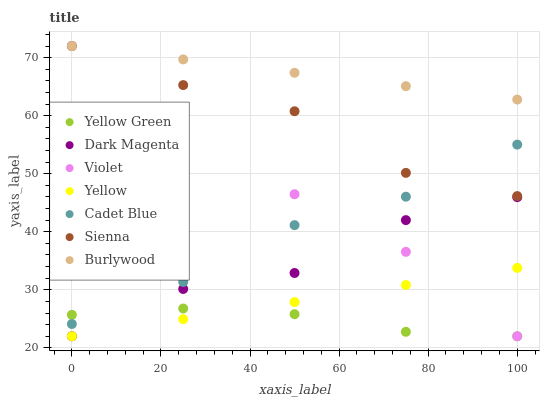Does Yellow Green have the minimum area under the curve?
Answer yes or no. Yes. Does Burlywood have the maximum area under the curve?
Answer yes or no. Yes. Does Burlywood have the minimum area under the curve?
Answer yes or no. No. Does Yellow Green have the maximum area under the curve?
Answer yes or no. No. Is Burlywood the smoothest?
Answer yes or no. Yes. Is Dark Magenta the roughest?
Answer yes or no. Yes. Is Yellow Green the smoothest?
Answer yes or no. No. Is Yellow Green the roughest?
Answer yes or no. No. Does Yellow Green have the lowest value?
Answer yes or no. Yes. Does Burlywood have the lowest value?
Answer yes or no. No. Does Violet have the highest value?
Answer yes or no. Yes. Does Yellow Green have the highest value?
Answer yes or no. No. Is Cadet Blue less than Burlywood?
Answer yes or no. Yes. Is Cadet Blue greater than Yellow?
Answer yes or no. Yes. Does Sienna intersect Violet?
Answer yes or no. Yes. Is Sienna less than Violet?
Answer yes or no. No. Is Sienna greater than Violet?
Answer yes or no. No. Does Cadet Blue intersect Burlywood?
Answer yes or no. No. 